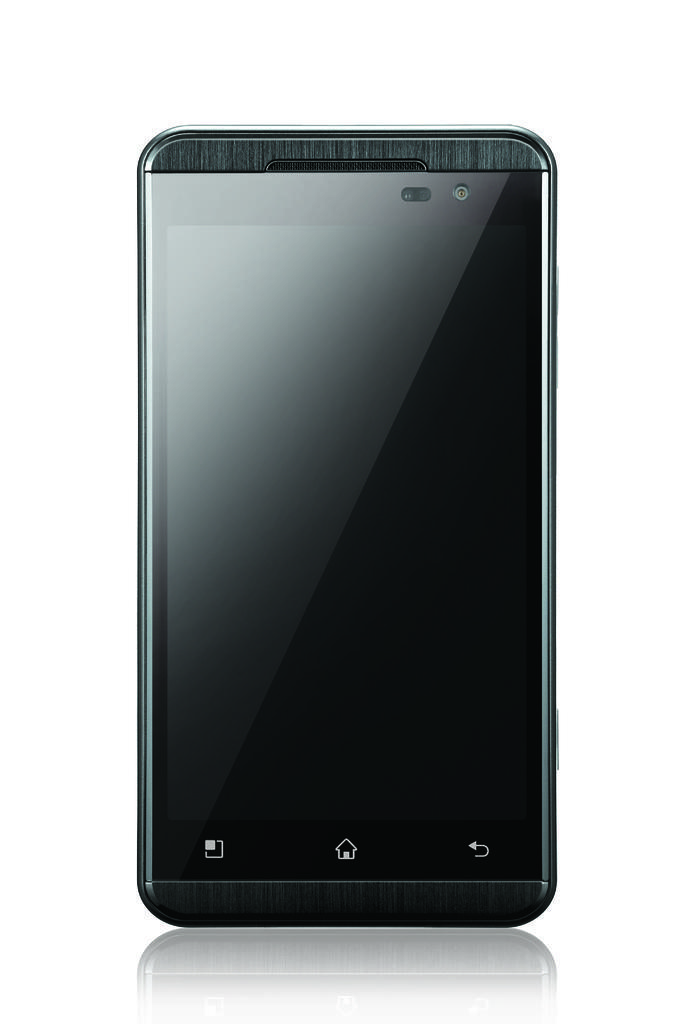Can you describe this image briefly? In this image I can see a mobile which is black in color and the white colored background. 